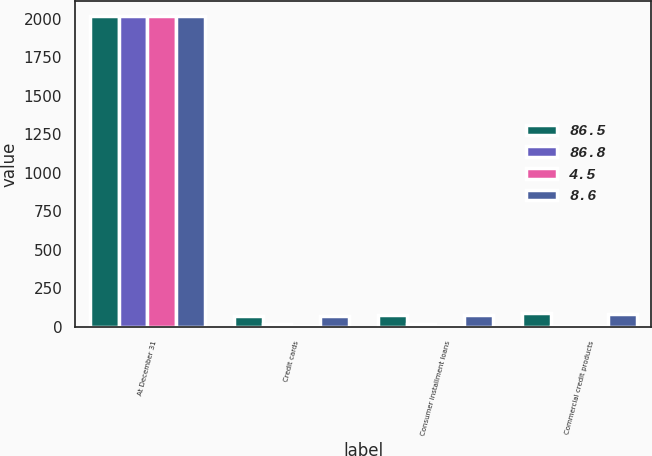<chart> <loc_0><loc_0><loc_500><loc_500><stacked_bar_chart><ecel><fcel>At December 31<fcel>Credit cards<fcel>Consumer installment loans<fcel>Commercial credit products<nl><fcel>86.5<fcel>2015<fcel>73<fcel>77.7<fcel>86.8<nl><fcel>86.8<fcel>2015<fcel>19.8<fcel>16.6<fcel>8.7<nl><fcel>4.5<fcel>2015<fcel>7.2<fcel>5.7<fcel>4.5<nl><fcel>8.6<fcel>2014<fcel>72.5<fcel>78.9<fcel>86.5<nl></chart> 